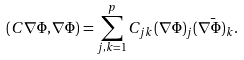Convert formula to latex. <formula><loc_0><loc_0><loc_500><loc_500>( C \nabla \Phi , \nabla \Phi ) = \sum _ { j , k = 1 } ^ { p } C _ { j k } ( \nabla \Phi ) _ { j } \bar { ( \nabla \Phi ) _ { k } } .</formula> 